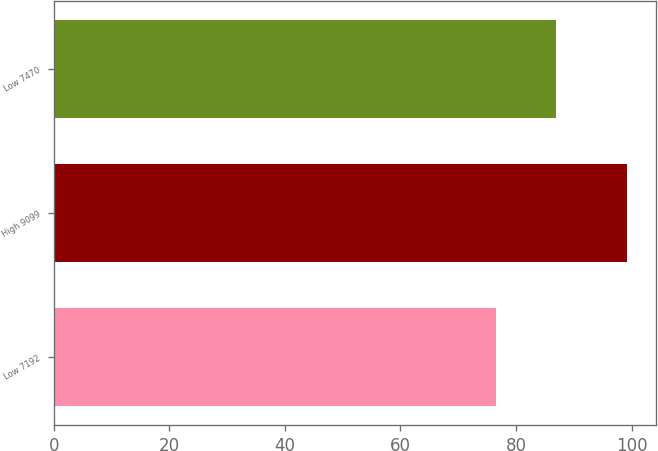Convert chart. <chart><loc_0><loc_0><loc_500><loc_500><bar_chart><fcel>Low 7192<fcel>High 9099<fcel>Low 7470<nl><fcel>76.51<fcel>99.24<fcel>86.91<nl></chart> 